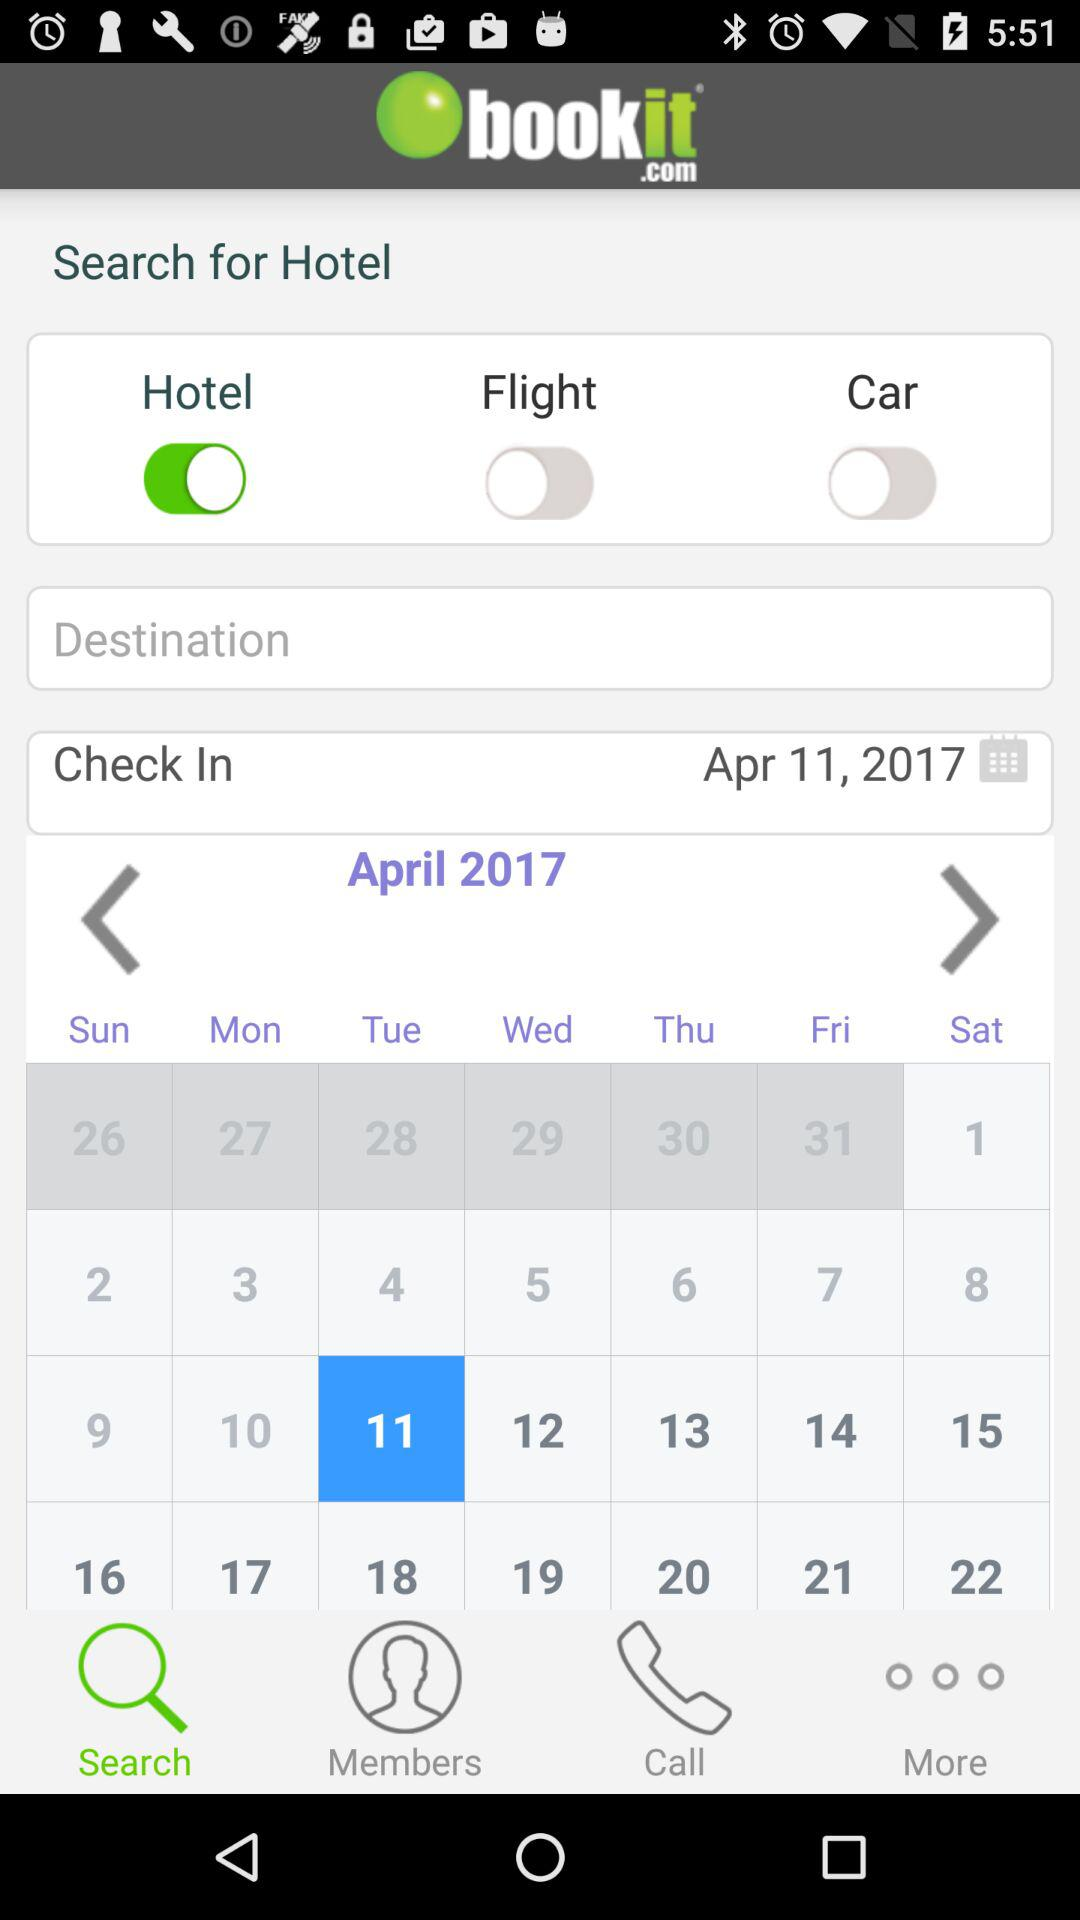What's the selected date on the calendar? The selected date is Tuesday, April 11, 2017. 